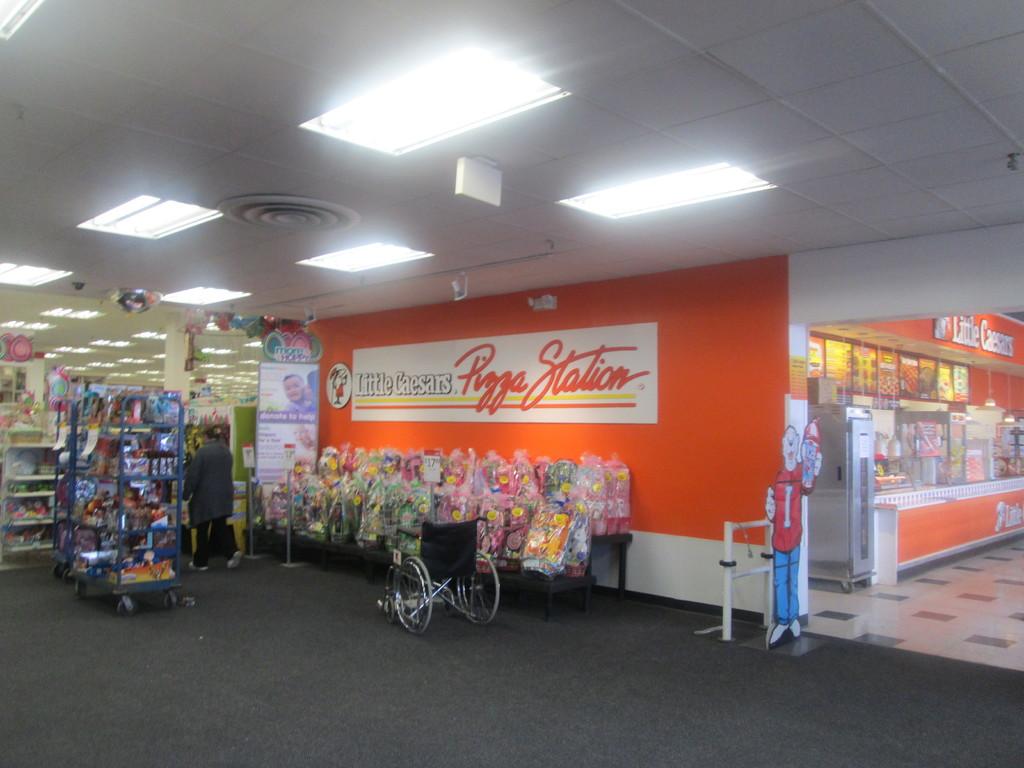What is the name of this place?
Offer a very short reply. Little ceasars pizza station. 